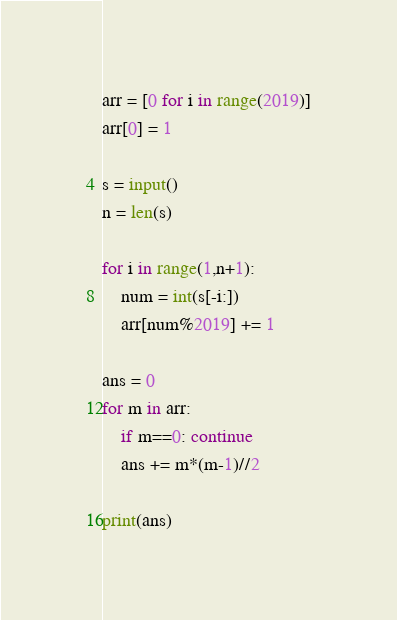Convert code to text. <code><loc_0><loc_0><loc_500><loc_500><_Python_>arr = [0 for i in range(2019)]
arr[0] = 1

s = input()
n = len(s)

for i in range(1,n+1):
    num = int(s[-i:])
    arr[num%2019] += 1

ans = 0
for m in arr:
    if m==0: continue
    ans += m*(m-1)//2

print(ans)

</code> 